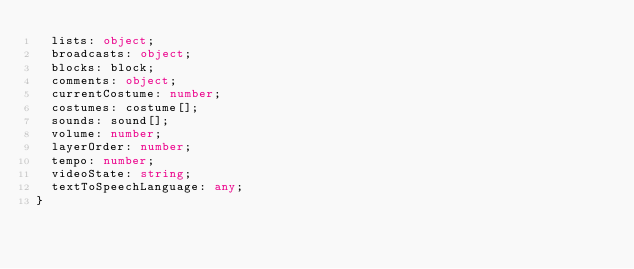Convert code to text. <code><loc_0><loc_0><loc_500><loc_500><_TypeScript_>  lists: object;
  broadcasts: object;
  blocks: block;
  comments: object;
  currentCostume: number;
  costumes: costume[];
  sounds: sound[];
  volume: number;
  layerOrder: number;
  tempo: number;
  videoState: string;
  textToSpeechLanguage: any;
}
</code> 